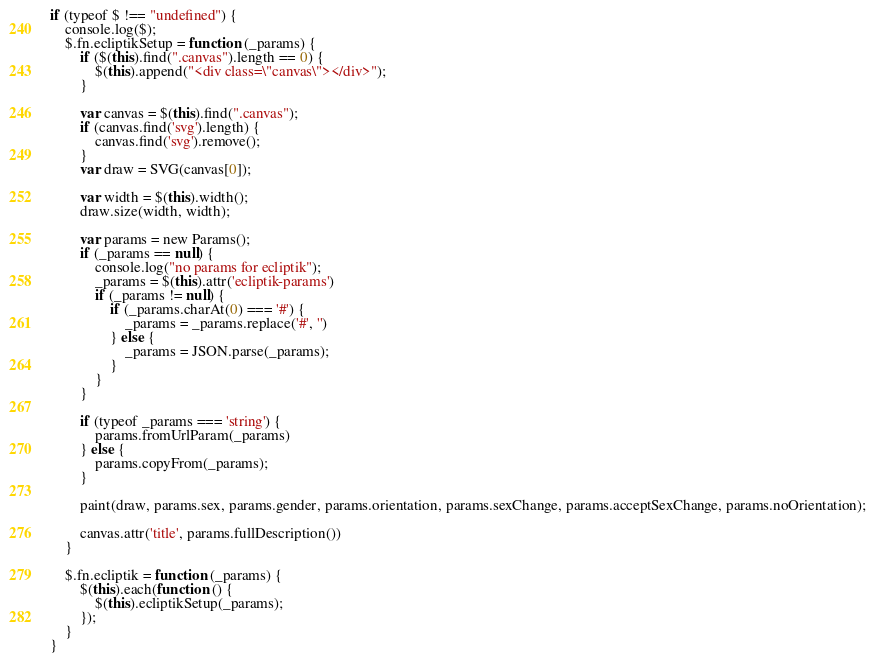<code> <loc_0><loc_0><loc_500><loc_500><_JavaScript_>if (typeof $ !== "undefined") {
    console.log($);
    $.fn.ecliptikSetup = function (_params) {
        if ($(this).find(".canvas").length == 0) {
            $(this).append("<div class=\"canvas\"></div>");
        }

        var canvas = $(this).find(".canvas");
        if (canvas.find('svg').length) {
            canvas.find('svg').remove();
        }
        var draw = SVG(canvas[0]);

        var width = $(this).width();
        draw.size(width, width);

        var params = new Params();
        if (_params == null) {
            console.log("no params for ecliptik");
            _params = $(this).attr('ecliptik-params')
            if (_params != null) {
                if (_params.charAt(0) === '#') {
                    _params = _params.replace('#', '')
                } else {
                    _params = JSON.parse(_params);
                }
            }
        }

        if (typeof _params === 'string') {
            params.fromUrlParam(_params)
        } else {
            params.copyFrom(_params);
        }

        paint(draw, params.sex, params.gender, params.orientation, params.sexChange, params.acceptSexChange, params.noOrientation);

        canvas.attr('title', params.fullDescription())
    }

    $.fn.ecliptik = function (_params) {
        $(this).each(function () {
            $(this).ecliptikSetup(_params);
        });
    }
}</code> 